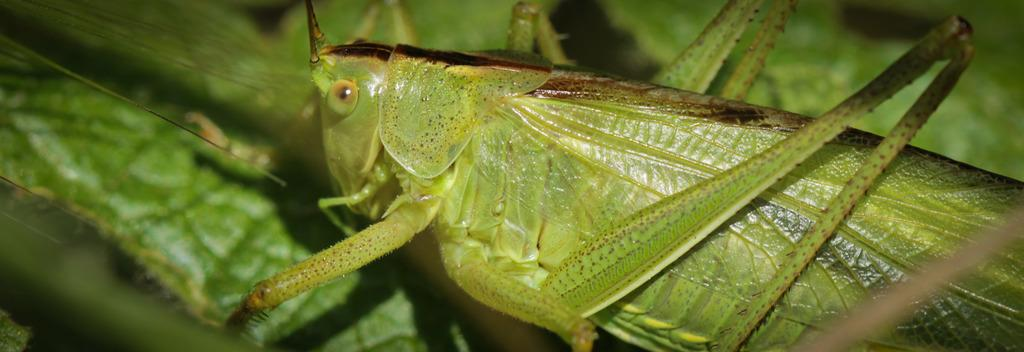What is the main subject of the image? There is a grasshopper in the image. Where is the grasshopper located? The grasshopper is on a leaf. Can you describe the background of the image? The background of the image is blurred. How many feet does the wine have in the image? There is no wine present in the image, and therefore no feet can be attributed to it. 